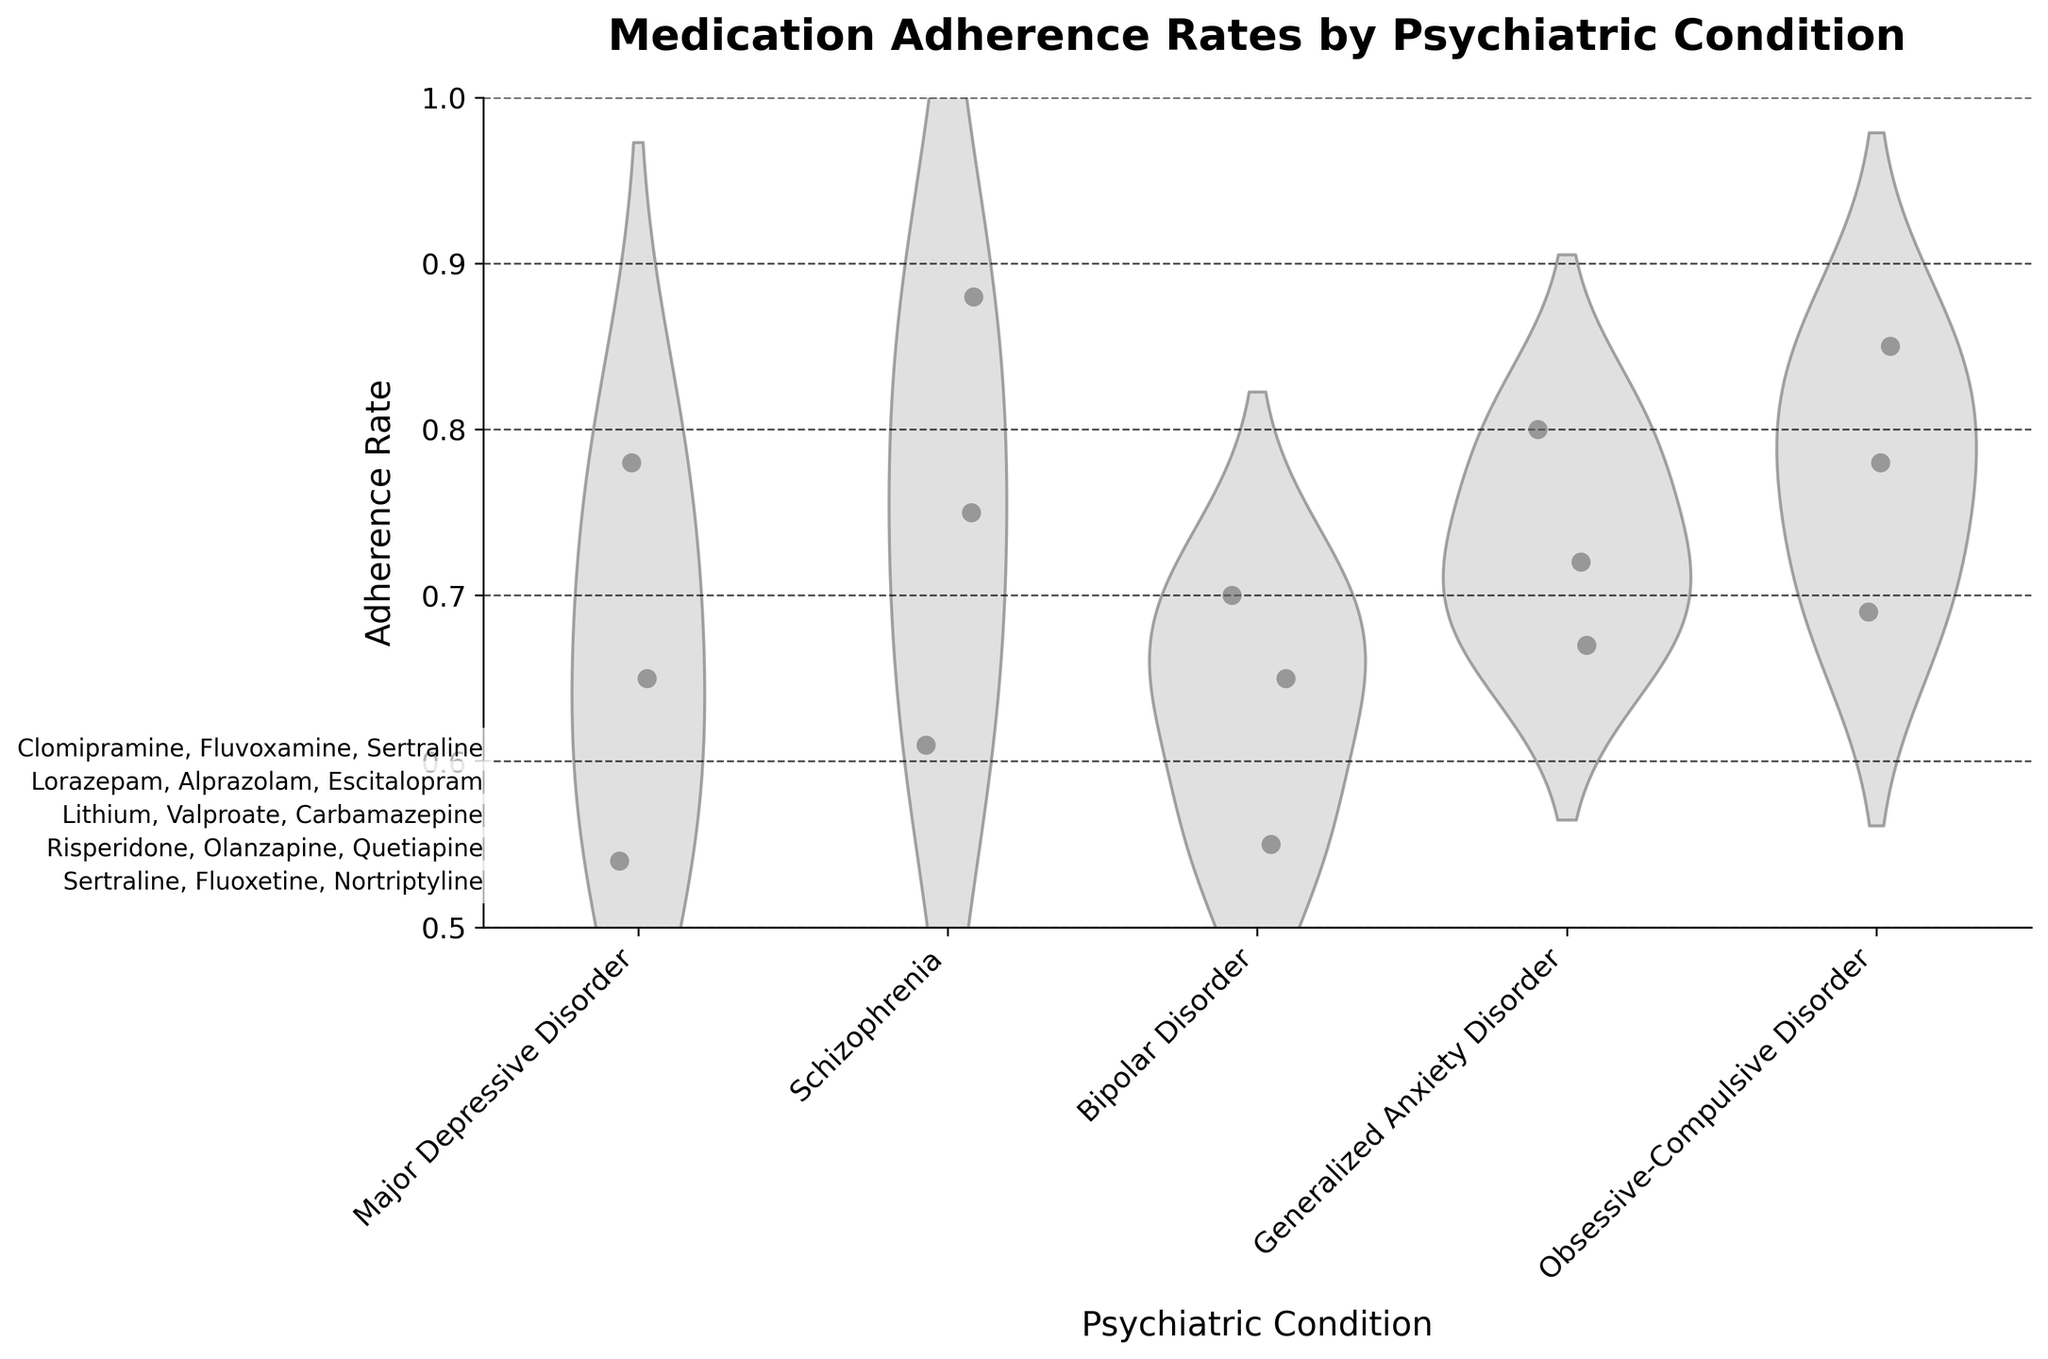What is the title of the figure? The title is indicated at the top of the figure in bold text. It summarizes the overall subject of the chart.
Answer: Medication Adherence Rates by Psychiatric Condition What is the adherence rate range shown on the y-axis? The y-axis has labeled ticks that indicate the minimum and maximum values displayed; these are from 0.5 to 1.0.
Answer: 0.5 to 1.0 Which psychiatric condition has the highest individual data point on the adherence rate? By observing the scatter points, the highest adherence rate point appears under the condition with the single highest value, which is Schizophrenia at 0.88 for Risperidone.
Answer: Schizophrenia What are the three medications plotted for Generalized Anxiety Disorder? The text annotations near the x-axis label for Generalized Anxiety Disorder list the medications used in this condition.
Answer: Lorazepam, Alprazolam, Escitalopram Which condition appears to have the lowest adherence rate data point? The lowest point among the jittered scatter points on the y-axis shows adherence around 0.54, which is under Major Depressive Disorder for Nortriptyline.
Answer: Major Depressive Disorder What is the average adherence rate for medications under Bipolar Disorder? Identify the adherence rates for medications under Bipolar Disorder and calculate the average: (0.70 + 0.65 + 0.55) / 3 = 1.90 / 3 = 0.6333.
Answer: 0.63 How does the adherence rate for Fluoxetine compare to Escitalopram? Locate adherence rates for both medications on the y-axis; Fluoxetine (0.65) is less than Escitalopram (0.67).
Answer: Fluoxetine: 0.65, Escitalopram: 0.67 Which condition has the highest median adherence rate in the violin plots? Each violin plot shows a thick central line representing the median. Schizophrenia exhibits the highest median adherence rate.
Answer: Schizophrenia 